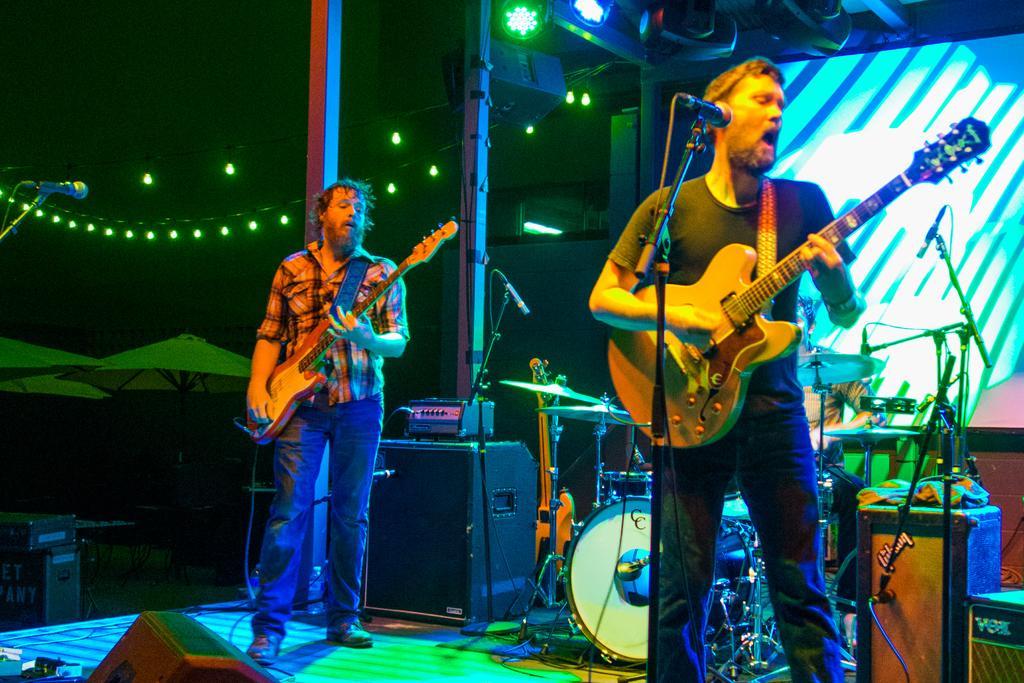In one or two sentences, can you explain what this image depicts? In this image we can see two persons are standing on the stage, there a man is singing, and holding a guitar in the hands, in front there is a microphone, and stand, at the back there are musical drums, there is a screen, there are lights, there are speakers, there are many lights. 